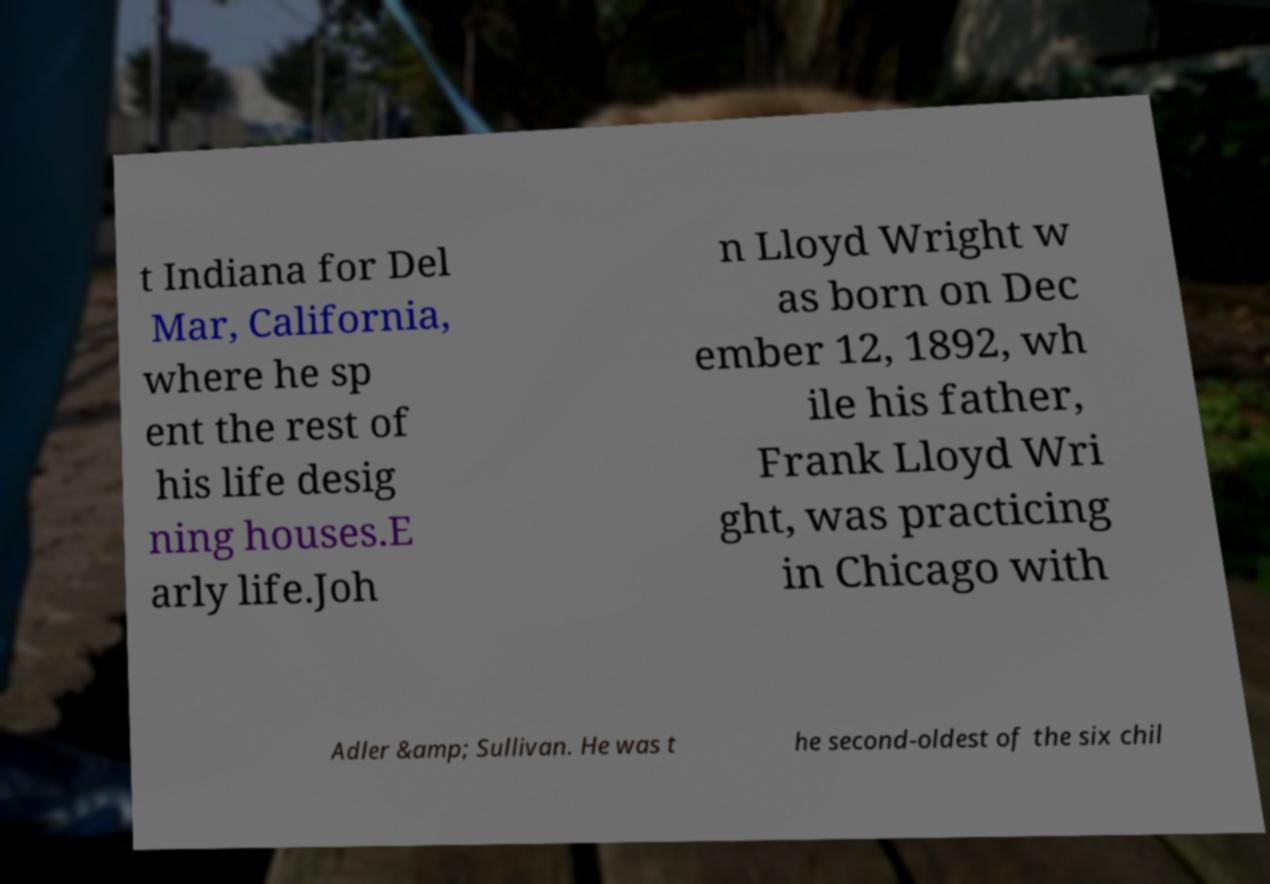Please identify and transcribe the text found in this image. t Indiana for Del Mar, California, where he sp ent the rest of his life desig ning houses.E arly life.Joh n Lloyd Wright w as born on Dec ember 12, 1892, wh ile his father, Frank Lloyd Wri ght, was practicing in Chicago with Adler &amp; Sullivan. He was t he second-oldest of the six chil 